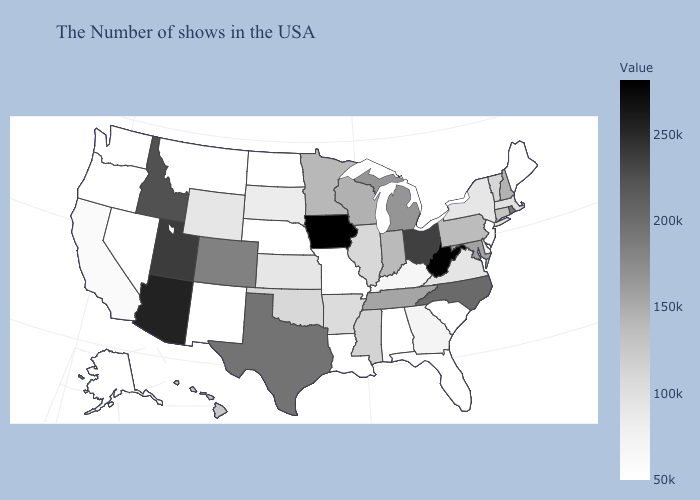Among the states that border Arizona , does Colorado have the lowest value?
Concise answer only. No. Among the states that border Alabama , does Georgia have the lowest value?
Be succinct. No. Which states have the lowest value in the South?
Keep it brief. South Carolina, Florida, Alabama, Louisiana. Which states have the lowest value in the USA?
Be succinct. Maine, New Jersey, South Carolina, Florida, Alabama, Louisiana, Missouri, Nebraska, North Dakota, New Mexico, Montana, Nevada, Washington, Oregon, Alaska. Does Vermont have the highest value in the Northeast?
Keep it brief. No. Which states hav the highest value in the Northeast?
Short answer required. Rhode Island. Does Nevada have the lowest value in the West?
Quick response, please. Yes. 